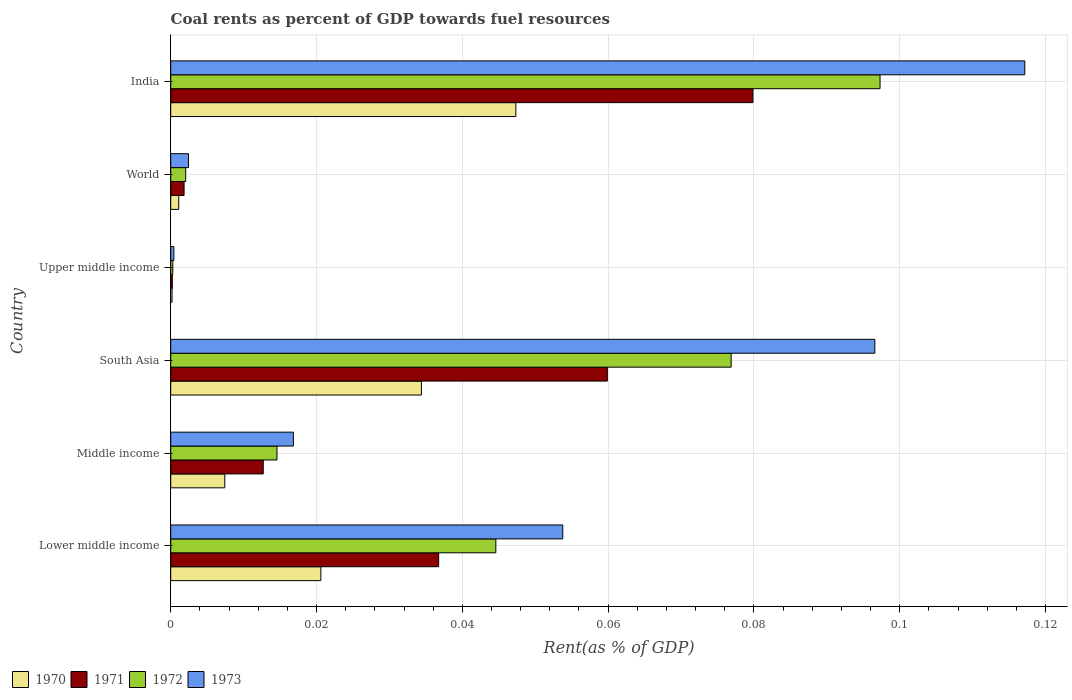How many groups of bars are there?
Provide a short and direct response. 6. How many bars are there on the 1st tick from the top?
Provide a succinct answer. 4. What is the label of the 3rd group of bars from the top?
Keep it short and to the point. Upper middle income. What is the coal rent in 1973 in Middle income?
Make the answer very short. 0.02. Across all countries, what is the maximum coal rent in 1972?
Your answer should be very brief. 0.1. Across all countries, what is the minimum coal rent in 1972?
Make the answer very short. 0. In which country was the coal rent in 1970 maximum?
Provide a succinct answer. India. In which country was the coal rent in 1972 minimum?
Your response must be concise. Upper middle income. What is the total coal rent in 1970 in the graph?
Ensure brevity in your answer.  0.11. What is the difference between the coal rent in 1970 in Middle income and that in Upper middle income?
Your answer should be compact. 0.01. What is the difference between the coal rent in 1973 in India and the coal rent in 1970 in World?
Provide a short and direct response. 0.12. What is the average coal rent in 1972 per country?
Your response must be concise. 0.04. What is the difference between the coal rent in 1971 and coal rent in 1970 in India?
Provide a succinct answer. 0.03. What is the ratio of the coal rent in 1970 in India to that in Upper middle income?
Give a very brief answer. 257.52. Is the difference between the coal rent in 1971 in South Asia and Upper middle income greater than the difference between the coal rent in 1970 in South Asia and Upper middle income?
Your answer should be compact. Yes. What is the difference between the highest and the second highest coal rent in 1973?
Give a very brief answer. 0.02. What is the difference between the highest and the lowest coal rent in 1970?
Your answer should be compact. 0.05. Is the sum of the coal rent in 1972 in India and Upper middle income greater than the maximum coal rent in 1973 across all countries?
Give a very brief answer. No. Is it the case that in every country, the sum of the coal rent in 1970 and coal rent in 1972 is greater than the sum of coal rent in 1973 and coal rent in 1971?
Your answer should be very brief. No. What does the 1st bar from the top in India represents?
Offer a very short reply. 1973. Is it the case that in every country, the sum of the coal rent in 1971 and coal rent in 1970 is greater than the coal rent in 1972?
Your answer should be very brief. Yes. How many bars are there?
Provide a succinct answer. 24. Are all the bars in the graph horizontal?
Keep it short and to the point. Yes. How many countries are there in the graph?
Your response must be concise. 6. Does the graph contain grids?
Offer a terse response. Yes. How many legend labels are there?
Your response must be concise. 4. What is the title of the graph?
Your response must be concise. Coal rents as percent of GDP towards fuel resources. Does "1997" appear as one of the legend labels in the graph?
Your response must be concise. No. What is the label or title of the X-axis?
Make the answer very short. Rent(as % of GDP). What is the Rent(as % of GDP) in 1970 in Lower middle income?
Offer a very short reply. 0.02. What is the Rent(as % of GDP) of 1971 in Lower middle income?
Keep it short and to the point. 0.04. What is the Rent(as % of GDP) of 1972 in Lower middle income?
Offer a terse response. 0.04. What is the Rent(as % of GDP) in 1973 in Lower middle income?
Ensure brevity in your answer.  0.05. What is the Rent(as % of GDP) in 1970 in Middle income?
Give a very brief answer. 0.01. What is the Rent(as % of GDP) in 1971 in Middle income?
Keep it short and to the point. 0.01. What is the Rent(as % of GDP) in 1972 in Middle income?
Your response must be concise. 0.01. What is the Rent(as % of GDP) of 1973 in Middle income?
Provide a succinct answer. 0.02. What is the Rent(as % of GDP) of 1970 in South Asia?
Provide a succinct answer. 0.03. What is the Rent(as % of GDP) of 1971 in South Asia?
Your response must be concise. 0.06. What is the Rent(as % of GDP) of 1972 in South Asia?
Keep it short and to the point. 0.08. What is the Rent(as % of GDP) in 1973 in South Asia?
Your response must be concise. 0.1. What is the Rent(as % of GDP) in 1970 in Upper middle income?
Provide a succinct answer. 0. What is the Rent(as % of GDP) in 1971 in Upper middle income?
Offer a very short reply. 0. What is the Rent(as % of GDP) of 1972 in Upper middle income?
Give a very brief answer. 0. What is the Rent(as % of GDP) of 1973 in Upper middle income?
Make the answer very short. 0. What is the Rent(as % of GDP) in 1970 in World?
Your response must be concise. 0. What is the Rent(as % of GDP) in 1971 in World?
Keep it short and to the point. 0. What is the Rent(as % of GDP) of 1972 in World?
Ensure brevity in your answer.  0. What is the Rent(as % of GDP) in 1973 in World?
Your response must be concise. 0. What is the Rent(as % of GDP) of 1970 in India?
Offer a terse response. 0.05. What is the Rent(as % of GDP) in 1971 in India?
Offer a terse response. 0.08. What is the Rent(as % of GDP) of 1972 in India?
Keep it short and to the point. 0.1. What is the Rent(as % of GDP) in 1973 in India?
Give a very brief answer. 0.12. Across all countries, what is the maximum Rent(as % of GDP) of 1970?
Your response must be concise. 0.05. Across all countries, what is the maximum Rent(as % of GDP) in 1971?
Give a very brief answer. 0.08. Across all countries, what is the maximum Rent(as % of GDP) in 1972?
Make the answer very short. 0.1. Across all countries, what is the maximum Rent(as % of GDP) of 1973?
Provide a short and direct response. 0.12. Across all countries, what is the minimum Rent(as % of GDP) of 1970?
Make the answer very short. 0. Across all countries, what is the minimum Rent(as % of GDP) in 1971?
Offer a very short reply. 0. Across all countries, what is the minimum Rent(as % of GDP) of 1972?
Make the answer very short. 0. Across all countries, what is the minimum Rent(as % of GDP) of 1973?
Offer a very short reply. 0. What is the total Rent(as % of GDP) in 1970 in the graph?
Keep it short and to the point. 0.11. What is the total Rent(as % of GDP) of 1971 in the graph?
Provide a short and direct response. 0.19. What is the total Rent(as % of GDP) in 1972 in the graph?
Provide a succinct answer. 0.24. What is the total Rent(as % of GDP) in 1973 in the graph?
Ensure brevity in your answer.  0.29. What is the difference between the Rent(as % of GDP) of 1970 in Lower middle income and that in Middle income?
Provide a succinct answer. 0.01. What is the difference between the Rent(as % of GDP) of 1971 in Lower middle income and that in Middle income?
Provide a succinct answer. 0.02. What is the difference between the Rent(as % of GDP) of 1973 in Lower middle income and that in Middle income?
Ensure brevity in your answer.  0.04. What is the difference between the Rent(as % of GDP) of 1970 in Lower middle income and that in South Asia?
Give a very brief answer. -0.01. What is the difference between the Rent(as % of GDP) in 1971 in Lower middle income and that in South Asia?
Your answer should be very brief. -0.02. What is the difference between the Rent(as % of GDP) in 1972 in Lower middle income and that in South Asia?
Offer a very short reply. -0.03. What is the difference between the Rent(as % of GDP) in 1973 in Lower middle income and that in South Asia?
Your answer should be very brief. -0.04. What is the difference between the Rent(as % of GDP) in 1970 in Lower middle income and that in Upper middle income?
Your answer should be compact. 0.02. What is the difference between the Rent(as % of GDP) of 1971 in Lower middle income and that in Upper middle income?
Your response must be concise. 0.04. What is the difference between the Rent(as % of GDP) in 1972 in Lower middle income and that in Upper middle income?
Offer a terse response. 0.04. What is the difference between the Rent(as % of GDP) of 1973 in Lower middle income and that in Upper middle income?
Keep it short and to the point. 0.05. What is the difference between the Rent(as % of GDP) of 1970 in Lower middle income and that in World?
Your answer should be very brief. 0.02. What is the difference between the Rent(as % of GDP) of 1971 in Lower middle income and that in World?
Offer a terse response. 0.03. What is the difference between the Rent(as % of GDP) in 1972 in Lower middle income and that in World?
Provide a short and direct response. 0.04. What is the difference between the Rent(as % of GDP) of 1973 in Lower middle income and that in World?
Keep it short and to the point. 0.05. What is the difference between the Rent(as % of GDP) in 1970 in Lower middle income and that in India?
Give a very brief answer. -0.03. What is the difference between the Rent(as % of GDP) in 1971 in Lower middle income and that in India?
Provide a short and direct response. -0.04. What is the difference between the Rent(as % of GDP) of 1972 in Lower middle income and that in India?
Your answer should be compact. -0.05. What is the difference between the Rent(as % of GDP) of 1973 in Lower middle income and that in India?
Your answer should be very brief. -0.06. What is the difference between the Rent(as % of GDP) in 1970 in Middle income and that in South Asia?
Your answer should be very brief. -0.03. What is the difference between the Rent(as % of GDP) in 1971 in Middle income and that in South Asia?
Make the answer very short. -0.05. What is the difference between the Rent(as % of GDP) in 1972 in Middle income and that in South Asia?
Provide a succinct answer. -0.06. What is the difference between the Rent(as % of GDP) of 1973 in Middle income and that in South Asia?
Provide a succinct answer. -0.08. What is the difference between the Rent(as % of GDP) of 1970 in Middle income and that in Upper middle income?
Keep it short and to the point. 0.01. What is the difference between the Rent(as % of GDP) in 1971 in Middle income and that in Upper middle income?
Offer a terse response. 0.01. What is the difference between the Rent(as % of GDP) in 1972 in Middle income and that in Upper middle income?
Ensure brevity in your answer.  0.01. What is the difference between the Rent(as % of GDP) of 1973 in Middle income and that in Upper middle income?
Provide a short and direct response. 0.02. What is the difference between the Rent(as % of GDP) of 1970 in Middle income and that in World?
Keep it short and to the point. 0.01. What is the difference between the Rent(as % of GDP) in 1971 in Middle income and that in World?
Keep it short and to the point. 0.01. What is the difference between the Rent(as % of GDP) of 1972 in Middle income and that in World?
Make the answer very short. 0.01. What is the difference between the Rent(as % of GDP) of 1973 in Middle income and that in World?
Make the answer very short. 0.01. What is the difference between the Rent(as % of GDP) of 1970 in Middle income and that in India?
Provide a succinct answer. -0.04. What is the difference between the Rent(as % of GDP) in 1971 in Middle income and that in India?
Your answer should be compact. -0.07. What is the difference between the Rent(as % of GDP) in 1972 in Middle income and that in India?
Keep it short and to the point. -0.08. What is the difference between the Rent(as % of GDP) of 1973 in Middle income and that in India?
Your response must be concise. -0.1. What is the difference between the Rent(as % of GDP) in 1970 in South Asia and that in Upper middle income?
Your answer should be compact. 0.03. What is the difference between the Rent(as % of GDP) of 1971 in South Asia and that in Upper middle income?
Give a very brief answer. 0.06. What is the difference between the Rent(as % of GDP) of 1972 in South Asia and that in Upper middle income?
Provide a succinct answer. 0.08. What is the difference between the Rent(as % of GDP) in 1973 in South Asia and that in Upper middle income?
Ensure brevity in your answer.  0.1. What is the difference between the Rent(as % of GDP) of 1971 in South Asia and that in World?
Provide a succinct answer. 0.06. What is the difference between the Rent(as % of GDP) of 1972 in South Asia and that in World?
Offer a terse response. 0.07. What is the difference between the Rent(as % of GDP) in 1973 in South Asia and that in World?
Your response must be concise. 0.09. What is the difference between the Rent(as % of GDP) of 1970 in South Asia and that in India?
Provide a short and direct response. -0.01. What is the difference between the Rent(as % of GDP) of 1971 in South Asia and that in India?
Give a very brief answer. -0.02. What is the difference between the Rent(as % of GDP) in 1972 in South Asia and that in India?
Offer a very short reply. -0.02. What is the difference between the Rent(as % of GDP) of 1973 in South Asia and that in India?
Keep it short and to the point. -0.02. What is the difference between the Rent(as % of GDP) in 1970 in Upper middle income and that in World?
Ensure brevity in your answer.  -0. What is the difference between the Rent(as % of GDP) in 1971 in Upper middle income and that in World?
Provide a short and direct response. -0. What is the difference between the Rent(as % of GDP) in 1972 in Upper middle income and that in World?
Make the answer very short. -0. What is the difference between the Rent(as % of GDP) of 1973 in Upper middle income and that in World?
Your answer should be very brief. -0. What is the difference between the Rent(as % of GDP) in 1970 in Upper middle income and that in India?
Offer a terse response. -0.05. What is the difference between the Rent(as % of GDP) in 1971 in Upper middle income and that in India?
Keep it short and to the point. -0.08. What is the difference between the Rent(as % of GDP) in 1972 in Upper middle income and that in India?
Provide a succinct answer. -0.1. What is the difference between the Rent(as % of GDP) in 1973 in Upper middle income and that in India?
Your response must be concise. -0.12. What is the difference between the Rent(as % of GDP) in 1970 in World and that in India?
Your response must be concise. -0.05. What is the difference between the Rent(as % of GDP) of 1971 in World and that in India?
Provide a short and direct response. -0.08. What is the difference between the Rent(as % of GDP) of 1972 in World and that in India?
Provide a short and direct response. -0.1. What is the difference between the Rent(as % of GDP) in 1973 in World and that in India?
Your answer should be very brief. -0.11. What is the difference between the Rent(as % of GDP) in 1970 in Lower middle income and the Rent(as % of GDP) in 1971 in Middle income?
Make the answer very short. 0.01. What is the difference between the Rent(as % of GDP) in 1970 in Lower middle income and the Rent(as % of GDP) in 1972 in Middle income?
Make the answer very short. 0.01. What is the difference between the Rent(as % of GDP) in 1970 in Lower middle income and the Rent(as % of GDP) in 1973 in Middle income?
Make the answer very short. 0. What is the difference between the Rent(as % of GDP) in 1971 in Lower middle income and the Rent(as % of GDP) in 1972 in Middle income?
Make the answer very short. 0.02. What is the difference between the Rent(as % of GDP) of 1971 in Lower middle income and the Rent(as % of GDP) of 1973 in Middle income?
Make the answer very short. 0.02. What is the difference between the Rent(as % of GDP) in 1972 in Lower middle income and the Rent(as % of GDP) in 1973 in Middle income?
Provide a succinct answer. 0.03. What is the difference between the Rent(as % of GDP) of 1970 in Lower middle income and the Rent(as % of GDP) of 1971 in South Asia?
Your answer should be very brief. -0.04. What is the difference between the Rent(as % of GDP) of 1970 in Lower middle income and the Rent(as % of GDP) of 1972 in South Asia?
Give a very brief answer. -0.06. What is the difference between the Rent(as % of GDP) in 1970 in Lower middle income and the Rent(as % of GDP) in 1973 in South Asia?
Your answer should be compact. -0.08. What is the difference between the Rent(as % of GDP) in 1971 in Lower middle income and the Rent(as % of GDP) in 1972 in South Asia?
Offer a very short reply. -0.04. What is the difference between the Rent(as % of GDP) in 1971 in Lower middle income and the Rent(as % of GDP) in 1973 in South Asia?
Provide a short and direct response. -0.06. What is the difference between the Rent(as % of GDP) in 1972 in Lower middle income and the Rent(as % of GDP) in 1973 in South Asia?
Your answer should be very brief. -0.05. What is the difference between the Rent(as % of GDP) of 1970 in Lower middle income and the Rent(as % of GDP) of 1971 in Upper middle income?
Provide a succinct answer. 0.02. What is the difference between the Rent(as % of GDP) in 1970 in Lower middle income and the Rent(as % of GDP) in 1972 in Upper middle income?
Offer a terse response. 0.02. What is the difference between the Rent(as % of GDP) of 1970 in Lower middle income and the Rent(as % of GDP) of 1973 in Upper middle income?
Provide a succinct answer. 0.02. What is the difference between the Rent(as % of GDP) in 1971 in Lower middle income and the Rent(as % of GDP) in 1972 in Upper middle income?
Provide a short and direct response. 0.04. What is the difference between the Rent(as % of GDP) of 1971 in Lower middle income and the Rent(as % of GDP) of 1973 in Upper middle income?
Offer a terse response. 0.04. What is the difference between the Rent(as % of GDP) of 1972 in Lower middle income and the Rent(as % of GDP) of 1973 in Upper middle income?
Keep it short and to the point. 0.04. What is the difference between the Rent(as % of GDP) of 1970 in Lower middle income and the Rent(as % of GDP) of 1971 in World?
Your answer should be compact. 0.02. What is the difference between the Rent(as % of GDP) of 1970 in Lower middle income and the Rent(as % of GDP) of 1972 in World?
Your response must be concise. 0.02. What is the difference between the Rent(as % of GDP) of 1970 in Lower middle income and the Rent(as % of GDP) of 1973 in World?
Provide a short and direct response. 0.02. What is the difference between the Rent(as % of GDP) of 1971 in Lower middle income and the Rent(as % of GDP) of 1972 in World?
Your answer should be compact. 0.03. What is the difference between the Rent(as % of GDP) of 1971 in Lower middle income and the Rent(as % of GDP) of 1973 in World?
Keep it short and to the point. 0.03. What is the difference between the Rent(as % of GDP) in 1972 in Lower middle income and the Rent(as % of GDP) in 1973 in World?
Keep it short and to the point. 0.04. What is the difference between the Rent(as % of GDP) in 1970 in Lower middle income and the Rent(as % of GDP) in 1971 in India?
Your response must be concise. -0.06. What is the difference between the Rent(as % of GDP) of 1970 in Lower middle income and the Rent(as % of GDP) of 1972 in India?
Make the answer very short. -0.08. What is the difference between the Rent(as % of GDP) of 1970 in Lower middle income and the Rent(as % of GDP) of 1973 in India?
Give a very brief answer. -0.1. What is the difference between the Rent(as % of GDP) of 1971 in Lower middle income and the Rent(as % of GDP) of 1972 in India?
Provide a short and direct response. -0.06. What is the difference between the Rent(as % of GDP) of 1971 in Lower middle income and the Rent(as % of GDP) of 1973 in India?
Your answer should be compact. -0.08. What is the difference between the Rent(as % of GDP) in 1972 in Lower middle income and the Rent(as % of GDP) in 1973 in India?
Make the answer very short. -0.07. What is the difference between the Rent(as % of GDP) of 1970 in Middle income and the Rent(as % of GDP) of 1971 in South Asia?
Keep it short and to the point. -0.05. What is the difference between the Rent(as % of GDP) of 1970 in Middle income and the Rent(as % of GDP) of 1972 in South Asia?
Your response must be concise. -0.07. What is the difference between the Rent(as % of GDP) of 1970 in Middle income and the Rent(as % of GDP) of 1973 in South Asia?
Offer a very short reply. -0.09. What is the difference between the Rent(as % of GDP) of 1971 in Middle income and the Rent(as % of GDP) of 1972 in South Asia?
Offer a very short reply. -0.06. What is the difference between the Rent(as % of GDP) of 1971 in Middle income and the Rent(as % of GDP) of 1973 in South Asia?
Make the answer very short. -0.08. What is the difference between the Rent(as % of GDP) of 1972 in Middle income and the Rent(as % of GDP) of 1973 in South Asia?
Keep it short and to the point. -0.08. What is the difference between the Rent(as % of GDP) of 1970 in Middle income and the Rent(as % of GDP) of 1971 in Upper middle income?
Provide a short and direct response. 0.01. What is the difference between the Rent(as % of GDP) in 1970 in Middle income and the Rent(as % of GDP) in 1972 in Upper middle income?
Make the answer very short. 0.01. What is the difference between the Rent(as % of GDP) of 1970 in Middle income and the Rent(as % of GDP) of 1973 in Upper middle income?
Keep it short and to the point. 0.01. What is the difference between the Rent(as % of GDP) in 1971 in Middle income and the Rent(as % of GDP) in 1972 in Upper middle income?
Ensure brevity in your answer.  0.01. What is the difference between the Rent(as % of GDP) of 1971 in Middle income and the Rent(as % of GDP) of 1973 in Upper middle income?
Offer a terse response. 0.01. What is the difference between the Rent(as % of GDP) in 1972 in Middle income and the Rent(as % of GDP) in 1973 in Upper middle income?
Provide a short and direct response. 0.01. What is the difference between the Rent(as % of GDP) in 1970 in Middle income and the Rent(as % of GDP) in 1971 in World?
Your answer should be very brief. 0.01. What is the difference between the Rent(as % of GDP) of 1970 in Middle income and the Rent(as % of GDP) of 1972 in World?
Your answer should be very brief. 0.01. What is the difference between the Rent(as % of GDP) in 1970 in Middle income and the Rent(as % of GDP) in 1973 in World?
Your answer should be very brief. 0.01. What is the difference between the Rent(as % of GDP) of 1971 in Middle income and the Rent(as % of GDP) of 1972 in World?
Your answer should be compact. 0.01. What is the difference between the Rent(as % of GDP) in 1971 in Middle income and the Rent(as % of GDP) in 1973 in World?
Provide a short and direct response. 0.01. What is the difference between the Rent(as % of GDP) in 1972 in Middle income and the Rent(as % of GDP) in 1973 in World?
Your response must be concise. 0.01. What is the difference between the Rent(as % of GDP) in 1970 in Middle income and the Rent(as % of GDP) in 1971 in India?
Offer a very short reply. -0.07. What is the difference between the Rent(as % of GDP) in 1970 in Middle income and the Rent(as % of GDP) in 1972 in India?
Give a very brief answer. -0.09. What is the difference between the Rent(as % of GDP) of 1970 in Middle income and the Rent(as % of GDP) of 1973 in India?
Your answer should be very brief. -0.11. What is the difference between the Rent(as % of GDP) in 1971 in Middle income and the Rent(as % of GDP) in 1972 in India?
Keep it short and to the point. -0.08. What is the difference between the Rent(as % of GDP) of 1971 in Middle income and the Rent(as % of GDP) of 1973 in India?
Your answer should be very brief. -0.1. What is the difference between the Rent(as % of GDP) in 1972 in Middle income and the Rent(as % of GDP) in 1973 in India?
Make the answer very short. -0.1. What is the difference between the Rent(as % of GDP) of 1970 in South Asia and the Rent(as % of GDP) of 1971 in Upper middle income?
Provide a short and direct response. 0.03. What is the difference between the Rent(as % of GDP) in 1970 in South Asia and the Rent(as % of GDP) in 1972 in Upper middle income?
Your response must be concise. 0.03. What is the difference between the Rent(as % of GDP) in 1970 in South Asia and the Rent(as % of GDP) in 1973 in Upper middle income?
Ensure brevity in your answer.  0.03. What is the difference between the Rent(as % of GDP) in 1971 in South Asia and the Rent(as % of GDP) in 1972 in Upper middle income?
Keep it short and to the point. 0.06. What is the difference between the Rent(as % of GDP) in 1971 in South Asia and the Rent(as % of GDP) in 1973 in Upper middle income?
Provide a succinct answer. 0.06. What is the difference between the Rent(as % of GDP) of 1972 in South Asia and the Rent(as % of GDP) of 1973 in Upper middle income?
Provide a succinct answer. 0.08. What is the difference between the Rent(as % of GDP) of 1970 in South Asia and the Rent(as % of GDP) of 1971 in World?
Provide a succinct answer. 0.03. What is the difference between the Rent(as % of GDP) of 1970 in South Asia and the Rent(as % of GDP) of 1972 in World?
Your answer should be compact. 0.03. What is the difference between the Rent(as % of GDP) in 1970 in South Asia and the Rent(as % of GDP) in 1973 in World?
Offer a very short reply. 0.03. What is the difference between the Rent(as % of GDP) in 1971 in South Asia and the Rent(as % of GDP) in 1972 in World?
Keep it short and to the point. 0.06. What is the difference between the Rent(as % of GDP) in 1971 in South Asia and the Rent(as % of GDP) in 1973 in World?
Make the answer very short. 0.06. What is the difference between the Rent(as % of GDP) in 1972 in South Asia and the Rent(as % of GDP) in 1973 in World?
Keep it short and to the point. 0.07. What is the difference between the Rent(as % of GDP) in 1970 in South Asia and the Rent(as % of GDP) in 1971 in India?
Offer a terse response. -0.05. What is the difference between the Rent(as % of GDP) in 1970 in South Asia and the Rent(as % of GDP) in 1972 in India?
Make the answer very short. -0.06. What is the difference between the Rent(as % of GDP) in 1970 in South Asia and the Rent(as % of GDP) in 1973 in India?
Give a very brief answer. -0.08. What is the difference between the Rent(as % of GDP) in 1971 in South Asia and the Rent(as % of GDP) in 1972 in India?
Your answer should be very brief. -0.04. What is the difference between the Rent(as % of GDP) of 1971 in South Asia and the Rent(as % of GDP) of 1973 in India?
Provide a succinct answer. -0.06. What is the difference between the Rent(as % of GDP) in 1972 in South Asia and the Rent(as % of GDP) in 1973 in India?
Ensure brevity in your answer.  -0.04. What is the difference between the Rent(as % of GDP) in 1970 in Upper middle income and the Rent(as % of GDP) in 1971 in World?
Offer a very short reply. -0. What is the difference between the Rent(as % of GDP) of 1970 in Upper middle income and the Rent(as % of GDP) of 1972 in World?
Your response must be concise. -0. What is the difference between the Rent(as % of GDP) of 1970 in Upper middle income and the Rent(as % of GDP) of 1973 in World?
Give a very brief answer. -0. What is the difference between the Rent(as % of GDP) in 1971 in Upper middle income and the Rent(as % of GDP) in 1972 in World?
Offer a terse response. -0. What is the difference between the Rent(as % of GDP) in 1971 in Upper middle income and the Rent(as % of GDP) in 1973 in World?
Your answer should be very brief. -0. What is the difference between the Rent(as % of GDP) in 1972 in Upper middle income and the Rent(as % of GDP) in 1973 in World?
Your response must be concise. -0. What is the difference between the Rent(as % of GDP) of 1970 in Upper middle income and the Rent(as % of GDP) of 1971 in India?
Your answer should be compact. -0.08. What is the difference between the Rent(as % of GDP) of 1970 in Upper middle income and the Rent(as % of GDP) of 1972 in India?
Your answer should be compact. -0.1. What is the difference between the Rent(as % of GDP) of 1970 in Upper middle income and the Rent(as % of GDP) of 1973 in India?
Keep it short and to the point. -0.12. What is the difference between the Rent(as % of GDP) in 1971 in Upper middle income and the Rent(as % of GDP) in 1972 in India?
Provide a short and direct response. -0.1. What is the difference between the Rent(as % of GDP) in 1971 in Upper middle income and the Rent(as % of GDP) in 1973 in India?
Your response must be concise. -0.12. What is the difference between the Rent(as % of GDP) in 1972 in Upper middle income and the Rent(as % of GDP) in 1973 in India?
Your answer should be compact. -0.12. What is the difference between the Rent(as % of GDP) of 1970 in World and the Rent(as % of GDP) of 1971 in India?
Keep it short and to the point. -0.08. What is the difference between the Rent(as % of GDP) of 1970 in World and the Rent(as % of GDP) of 1972 in India?
Offer a terse response. -0.1. What is the difference between the Rent(as % of GDP) in 1970 in World and the Rent(as % of GDP) in 1973 in India?
Keep it short and to the point. -0.12. What is the difference between the Rent(as % of GDP) of 1971 in World and the Rent(as % of GDP) of 1972 in India?
Keep it short and to the point. -0.1. What is the difference between the Rent(as % of GDP) in 1971 in World and the Rent(as % of GDP) in 1973 in India?
Your response must be concise. -0.12. What is the difference between the Rent(as % of GDP) of 1972 in World and the Rent(as % of GDP) of 1973 in India?
Keep it short and to the point. -0.12. What is the average Rent(as % of GDP) of 1970 per country?
Provide a short and direct response. 0.02. What is the average Rent(as % of GDP) in 1971 per country?
Give a very brief answer. 0.03. What is the average Rent(as % of GDP) in 1972 per country?
Offer a very short reply. 0.04. What is the average Rent(as % of GDP) in 1973 per country?
Offer a very short reply. 0.05. What is the difference between the Rent(as % of GDP) of 1970 and Rent(as % of GDP) of 1971 in Lower middle income?
Give a very brief answer. -0.02. What is the difference between the Rent(as % of GDP) in 1970 and Rent(as % of GDP) in 1972 in Lower middle income?
Ensure brevity in your answer.  -0.02. What is the difference between the Rent(as % of GDP) in 1970 and Rent(as % of GDP) in 1973 in Lower middle income?
Ensure brevity in your answer.  -0.03. What is the difference between the Rent(as % of GDP) in 1971 and Rent(as % of GDP) in 1972 in Lower middle income?
Offer a very short reply. -0.01. What is the difference between the Rent(as % of GDP) of 1971 and Rent(as % of GDP) of 1973 in Lower middle income?
Your response must be concise. -0.02. What is the difference between the Rent(as % of GDP) in 1972 and Rent(as % of GDP) in 1973 in Lower middle income?
Keep it short and to the point. -0.01. What is the difference between the Rent(as % of GDP) of 1970 and Rent(as % of GDP) of 1971 in Middle income?
Give a very brief answer. -0.01. What is the difference between the Rent(as % of GDP) in 1970 and Rent(as % of GDP) in 1972 in Middle income?
Offer a very short reply. -0.01. What is the difference between the Rent(as % of GDP) in 1970 and Rent(as % of GDP) in 1973 in Middle income?
Offer a very short reply. -0.01. What is the difference between the Rent(as % of GDP) in 1971 and Rent(as % of GDP) in 1972 in Middle income?
Provide a succinct answer. -0. What is the difference between the Rent(as % of GDP) in 1971 and Rent(as % of GDP) in 1973 in Middle income?
Make the answer very short. -0. What is the difference between the Rent(as % of GDP) in 1972 and Rent(as % of GDP) in 1973 in Middle income?
Provide a short and direct response. -0. What is the difference between the Rent(as % of GDP) of 1970 and Rent(as % of GDP) of 1971 in South Asia?
Your response must be concise. -0.03. What is the difference between the Rent(as % of GDP) of 1970 and Rent(as % of GDP) of 1972 in South Asia?
Offer a terse response. -0.04. What is the difference between the Rent(as % of GDP) of 1970 and Rent(as % of GDP) of 1973 in South Asia?
Keep it short and to the point. -0.06. What is the difference between the Rent(as % of GDP) in 1971 and Rent(as % of GDP) in 1972 in South Asia?
Your response must be concise. -0.02. What is the difference between the Rent(as % of GDP) of 1971 and Rent(as % of GDP) of 1973 in South Asia?
Your answer should be very brief. -0.04. What is the difference between the Rent(as % of GDP) of 1972 and Rent(as % of GDP) of 1973 in South Asia?
Offer a very short reply. -0.02. What is the difference between the Rent(as % of GDP) in 1970 and Rent(as % of GDP) in 1972 in Upper middle income?
Your response must be concise. -0. What is the difference between the Rent(as % of GDP) in 1970 and Rent(as % of GDP) in 1973 in Upper middle income?
Give a very brief answer. -0. What is the difference between the Rent(as % of GDP) of 1971 and Rent(as % of GDP) of 1972 in Upper middle income?
Make the answer very short. -0. What is the difference between the Rent(as % of GDP) in 1971 and Rent(as % of GDP) in 1973 in Upper middle income?
Your answer should be very brief. -0. What is the difference between the Rent(as % of GDP) of 1972 and Rent(as % of GDP) of 1973 in Upper middle income?
Make the answer very short. -0. What is the difference between the Rent(as % of GDP) in 1970 and Rent(as % of GDP) in 1971 in World?
Give a very brief answer. -0. What is the difference between the Rent(as % of GDP) in 1970 and Rent(as % of GDP) in 1972 in World?
Keep it short and to the point. -0. What is the difference between the Rent(as % of GDP) in 1970 and Rent(as % of GDP) in 1973 in World?
Provide a succinct answer. -0. What is the difference between the Rent(as % of GDP) of 1971 and Rent(as % of GDP) of 1972 in World?
Provide a short and direct response. -0. What is the difference between the Rent(as % of GDP) in 1971 and Rent(as % of GDP) in 1973 in World?
Keep it short and to the point. -0. What is the difference between the Rent(as % of GDP) of 1972 and Rent(as % of GDP) of 1973 in World?
Offer a very short reply. -0. What is the difference between the Rent(as % of GDP) in 1970 and Rent(as % of GDP) in 1971 in India?
Offer a very short reply. -0.03. What is the difference between the Rent(as % of GDP) of 1970 and Rent(as % of GDP) of 1973 in India?
Ensure brevity in your answer.  -0.07. What is the difference between the Rent(as % of GDP) of 1971 and Rent(as % of GDP) of 1972 in India?
Keep it short and to the point. -0.02. What is the difference between the Rent(as % of GDP) of 1971 and Rent(as % of GDP) of 1973 in India?
Make the answer very short. -0.04. What is the difference between the Rent(as % of GDP) of 1972 and Rent(as % of GDP) of 1973 in India?
Your answer should be compact. -0.02. What is the ratio of the Rent(as % of GDP) of 1970 in Lower middle income to that in Middle income?
Your answer should be compact. 2.78. What is the ratio of the Rent(as % of GDP) in 1971 in Lower middle income to that in Middle income?
Make the answer very short. 2.9. What is the ratio of the Rent(as % of GDP) of 1972 in Lower middle income to that in Middle income?
Keep it short and to the point. 3.06. What is the ratio of the Rent(as % of GDP) of 1973 in Lower middle income to that in Middle income?
Provide a succinct answer. 3.2. What is the ratio of the Rent(as % of GDP) in 1970 in Lower middle income to that in South Asia?
Your answer should be very brief. 0.6. What is the ratio of the Rent(as % of GDP) of 1971 in Lower middle income to that in South Asia?
Your response must be concise. 0.61. What is the ratio of the Rent(as % of GDP) in 1972 in Lower middle income to that in South Asia?
Keep it short and to the point. 0.58. What is the ratio of the Rent(as % of GDP) of 1973 in Lower middle income to that in South Asia?
Your answer should be very brief. 0.56. What is the ratio of the Rent(as % of GDP) of 1970 in Lower middle income to that in Upper middle income?
Keep it short and to the point. 112.03. What is the ratio of the Rent(as % of GDP) of 1971 in Lower middle income to that in Upper middle income?
Provide a short and direct response. 167.98. What is the ratio of the Rent(as % of GDP) in 1972 in Lower middle income to that in Upper middle income?
Your response must be concise. 156.82. What is the ratio of the Rent(as % of GDP) of 1973 in Lower middle income to that in Upper middle income?
Give a very brief answer. 124.82. What is the ratio of the Rent(as % of GDP) in 1970 in Lower middle income to that in World?
Offer a very short reply. 18.71. What is the ratio of the Rent(as % of GDP) of 1971 in Lower middle income to that in World?
Your answer should be compact. 20.06. What is the ratio of the Rent(as % of GDP) of 1972 in Lower middle income to that in World?
Provide a succinct answer. 21.7. What is the ratio of the Rent(as % of GDP) of 1973 in Lower middle income to that in World?
Make the answer very short. 22.07. What is the ratio of the Rent(as % of GDP) of 1970 in Lower middle income to that in India?
Provide a succinct answer. 0.44. What is the ratio of the Rent(as % of GDP) in 1971 in Lower middle income to that in India?
Your response must be concise. 0.46. What is the ratio of the Rent(as % of GDP) of 1972 in Lower middle income to that in India?
Provide a succinct answer. 0.46. What is the ratio of the Rent(as % of GDP) of 1973 in Lower middle income to that in India?
Your answer should be compact. 0.46. What is the ratio of the Rent(as % of GDP) in 1970 in Middle income to that in South Asia?
Your response must be concise. 0.22. What is the ratio of the Rent(as % of GDP) in 1971 in Middle income to that in South Asia?
Give a very brief answer. 0.21. What is the ratio of the Rent(as % of GDP) of 1972 in Middle income to that in South Asia?
Offer a very short reply. 0.19. What is the ratio of the Rent(as % of GDP) of 1973 in Middle income to that in South Asia?
Offer a very short reply. 0.17. What is the ratio of the Rent(as % of GDP) in 1970 in Middle income to that in Upper middle income?
Give a very brief answer. 40.36. What is the ratio of the Rent(as % of GDP) in 1971 in Middle income to that in Upper middle income?
Provide a succinct answer. 58.01. What is the ratio of the Rent(as % of GDP) of 1972 in Middle income to that in Upper middle income?
Offer a very short reply. 51.25. What is the ratio of the Rent(as % of GDP) in 1973 in Middle income to that in Upper middle income?
Provide a succinct answer. 39.04. What is the ratio of the Rent(as % of GDP) of 1970 in Middle income to that in World?
Keep it short and to the point. 6.74. What is the ratio of the Rent(as % of GDP) in 1971 in Middle income to that in World?
Ensure brevity in your answer.  6.93. What is the ratio of the Rent(as % of GDP) of 1972 in Middle income to that in World?
Offer a very short reply. 7.09. What is the ratio of the Rent(as % of GDP) in 1973 in Middle income to that in World?
Give a very brief answer. 6.91. What is the ratio of the Rent(as % of GDP) of 1970 in Middle income to that in India?
Your response must be concise. 0.16. What is the ratio of the Rent(as % of GDP) in 1971 in Middle income to that in India?
Make the answer very short. 0.16. What is the ratio of the Rent(as % of GDP) in 1972 in Middle income to that in India?
Offer a terse response. 0.15. What is the ratio of the Rent(as % of GDP) of 1973 in Middle income to that in India?
Your answer should be very brief. 0.14. What is the ratio of the Rent(as % of GDP) in 1970 in South Asia to that in Upper middle income?
Your response must be concise. 187.05. What is the ratio of the Rent(as % of GDP) of 1971 in South Asia to that in Upper middle income?
Give a very brief answer. 273.74. What is the ratio of the Rent(as % of GDP) of 1972 in South Asia to that in Upper middle income?
Your answer should be compact. 270.32. What is the ratio of the Rent(as % of GDP) of 1973 in South Asia to that in Upper middle income?
Your response must be concise. 224.18. What is the ratio of the Rent(as % of GDP) of 1970 in South Asia to that in World?
Provide a succinct answer. 31.24. What is the ratio of the Rent(as % of GDP) in 1971 in South Asia to that in World?
Give a very brief answer. 32.69. What is the ratio of the Rent(as % of GDP) of 1972 in South Asia to that in World?
Make the answer very short. 37.41. What is the ratio of the Rent(as % of GDP) of 1973 in South Asia to that in World?
Ensure brevity in your answer.  39.65. What is the ratio of the Rent(as % of GDP) in 1970 in South Asia to that in India?
Your response must be concise. 0.73. What is the ratio of the Rent(as % of GDP) in 1971 in South Asia to that in India?
Ensure brevity in your answer.  0.75. What is the ratio of the Rent(as % of GDP) in 1972 in South Asia to that in India?
Keep it short and to the point. 0.79. What is the ratio of the Rent(as % of GDP) in 1973 in South Asia to that in India?
Provide a succinct answer. 0.82. What is the ratio of the Rent(as % of GDP) of 1970 in Upper middle income to that in World?
Offer a terse response. 0.17. What is the ratio of the Rent(as % of GDP) in 1971 in Upper middle income to that in World?
Offer a very short reply. 0.12. What is the ratio of the Rent(as % of GDP) in 1972 in Upper middle income to that in World?
Your answer should be compact. 0.14. What is the ratio of the Rent(as % of GDP) in 1973 in Upper middle income to that in World?
Provide a succinct answer. 0.18. What is the ratio of the Rent(as % of GDP) of 1970 in Upper middle income to that in India?
Keep it short and to the point. 0. What is the ratio of the Rent(as % of GDP) of 1971 in Upper middle income to that in India?
Make the answer very short. 0. What is the ratio of the Rent(as % of GDP) in 1972 in Upper middle income to that in India?
Ensure brevity in your answer.  0. What is the ratio of the Rent(as % of GDP) of 1973 in Upper middle income to that in India?
Ensure brevity in your answer.  0. What is the ratio of the Rent(as % of GDP) in 1970 in World to that in India?
Offer a very short reply. 0.02. What is the ratio of the Rent(as % of GDP) in 1971 in World to that in India?
Your answer should be very brief. 0.02. What is the ratio of the Rent(as % of GDP) of 1972 in World to that in India?
Keep it short and to the point. 0.02. What is the ratio of the Rent(as % of GDP) of 1973 in World to that in India?
Provide a short and direct response. 0.02. What is the difference between the highest and the second highest Rent(as % of GDP) of 1970?
Provide a short and direct response. 0.01. What is the difference between the highest and the second highest Rent(as % of GDP) in 1972?
Make the answer very short. 0.02. What is the difference between the highest and the second highest Rent(as % of GDP) of 1973?
Offer a terse response. 0.02. What is the difference between the highest and the lowest Rent(as % of GDP) in 1970?
Offer a terse response. 0.05. What is the difference between the highest and the lowest Rent(as % of GDP) in 1971?
Provide a succinct answer. 0.08. What is the difference between the highest and the lowest Rent(as % of GDP) of 1972?
Provide a succinct answer. 0.1. What is the difference between the highest and the lowest Rent(as % of GDP) in 1973?
Offer a very short reply. 0.12. 